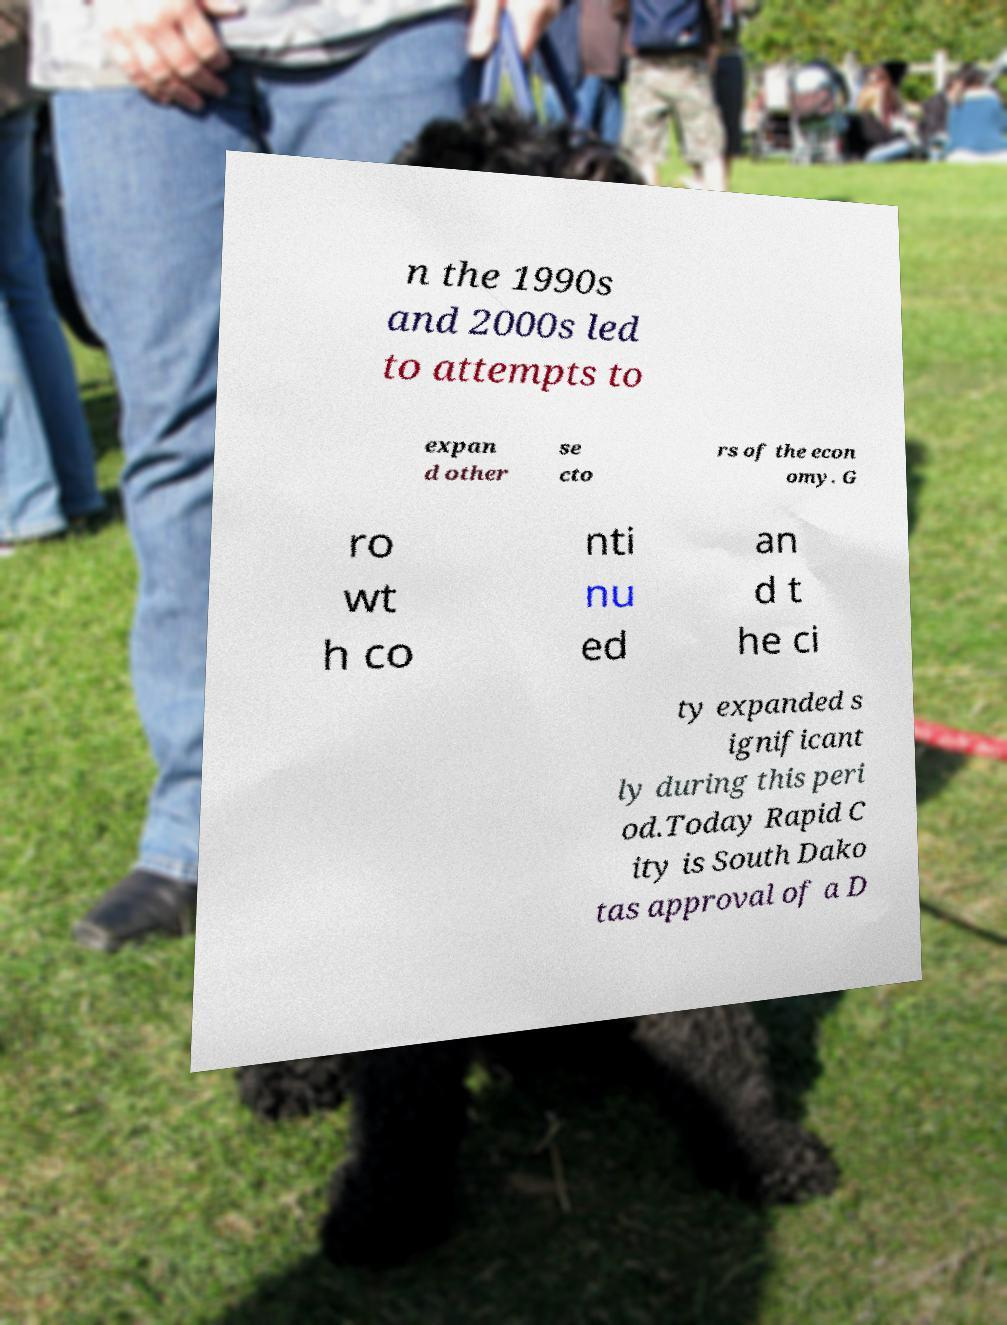What messages or text are displayed in this image? I need them in a readable, typed format. n the 1990s and 2000s led to attempts to expan d other se cto rs of the econ omy. G ro wt h co nti nu ed an d t he ci ty expanded s ignificant ly during this peri od.Today Rapid C ity is South Dako tas approval of a D 